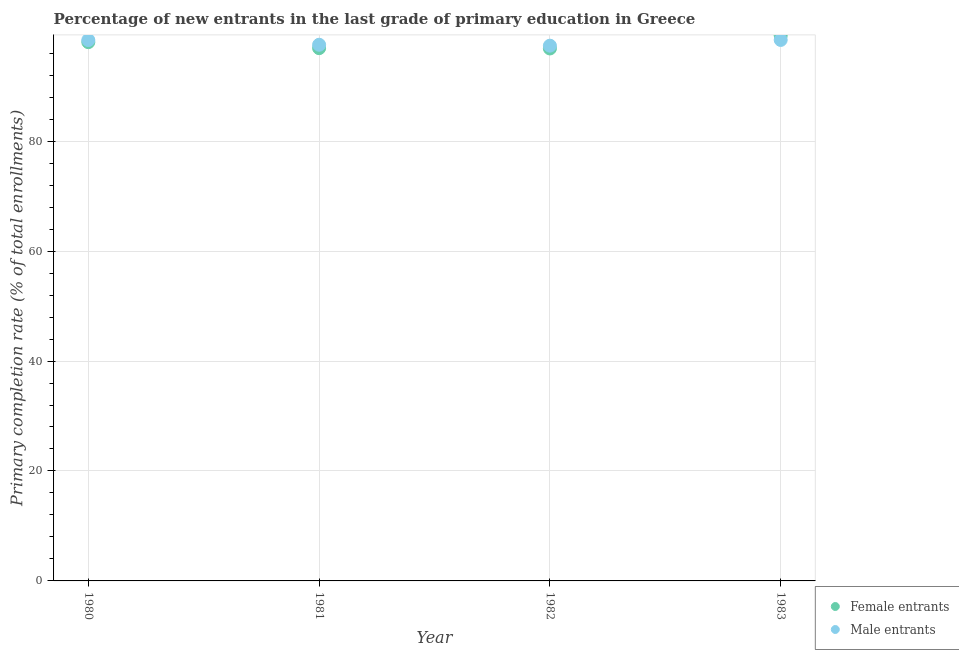What is the primary completion rate of female entrants in 1983?
Offer a very short reply. 99.21. Across all years, what is the maximum primary completion rate of male entrants?
Keep it short and to the point. 98.41. Across all years, what is the minimum primary completion rate of male entrants?
Provide a succinct answer. 97.36. In which year was the primary completion rate of female entrants maximum?
Offer a terse response. 1983. In which year was the primary completion rate of female entrants minimum?
Provide a short and direct response. 1982. What is the total primary completion rate of male entrants in the graph?
Provide a succinct answer. 391.69. What is the difference between the primary completion rate of female entrants in 1980 and that in 1981?
Offer a terse response. 1.09. What is the difference between the primary completion rate of male entrants in 1981 and the primary completion rate of female entrants in 1983?
Offer a terse response. -1.68. What is the average primary completion rate of female entrants per year?
Offer a terse response. 97.75. In the year 1983, what is the difference between the primary completion rate of male entrants and primary completion rate of female entrants?
Offer a very short reply. -0.8. In how many years, is the primary completion rate of male entrants greater than 24 %?
Keep it short and to the point. 4. What is the ratio of the primary completion rate of male entrants in 1982 to that in 1983?
Offer a very short reply. 0.99. Is the difference between the primary completion rate of female entrants in 1981 and 1983 greater than the difference between the primary completion rate of male entrants in 1981 and 1983?
Your response must be concise. No. What is the difference between the highest and the second highest primary completion rate of male entrants?
Keep it short and to the point. 0.02. What is the difference between the highest and the lowest primary completion rate of female entrants?
Ensure brevity in your answer.  2.36. In how many years, is the primary completion rate of male entrants greater than the average primary completion rate of male entrants taken over all years?
Offer a very short reply. 2. Is the sum of the primary completion rate of female entrants in 1980 and 1982 greater than the maximum primary completion rate of male entrants across all years?
Make the answer very short. Yes. How many dotlines are there?
Ensure brevity in your answer.  2. How many years are there in the graph?
Ensure brevity in your answer.  4. Does the graph contain grids?
Offer a very short reply. Yes. How many legend labels are there?
Your response must be concise. 2. How are the legend labels stacked?
Provide a succinct answer. Vertical. What is the title of the graph?
Provide a short and direct response. Percentage of new entrants in the last grade of primary education in Greece. Does "Official aid received" appear as one of the legend labels in the graph?
Ensure brevity in your answer.  No. What is the label or title of the Y-axis?
Ensure brevity in your answer.  Primary completion rate (% of total enrollments). What is the Primary completion rate (% of total enrollments) of Female entrants in 1980?
Make the answer very short. 98.01. What is the Primary completion rate (% of total enrollments) in Male entrants in 1980?
Provide a succinct answer. 98.39. What is the Primary completion rate (% of total enrollments) in Female entrants in 1981?
Your response must be concise. 96.91. What is the Primary completion rate (% of total enrollments) in Male entrants in 1981?
Your answer should be very brief. 97.53. What is the Primary completion rate (% of total enrollments) in Female entrants in 1982?
Your response must be concise. 96.86. What is the Primary completion rate (% of total enrollments) in Male entrants in 1982?
Ensure brevity in your answer.  97.36. What is the Primary completion rate (% of total enrollments) of Female entrants in 1983?
Your response must be concise. 99.21. What is the Primary completion rate (% of total enrollments) in Male entrants in 1983?
Make the answer very short. 98.41. Across all years, what is the maximum Primary completion rate (% of total enrollments) of Female entrants?
Offer a terse response. 99.21. Across all years, what is the maximum Primary completion rate (% of total enrollments) of Male entrants?
Your answer should be compact. 98.41. Across all years, what is the minimum Primary completion rate (% of total enrollments) of Female entrants?
Your answer should be compact. 96.86. Across all years, what is the minimum Primary completion rate (% of total enrollments) in Male entrants?
Provide a short and direct response. 97.36. What is the total Primary completion rate (% of total enrollments) in Female entrants in the graph?
Offer a very short reply. 390.99. What is the total Primary completion rate (% of total enrollments) of Male entrants in the graph?
Provide a succinct answer. 391.69. What is the difference between the Primary completion rate (% of total enrollments) in Female entrants in 1980 and that in 1981?
Offer a very short reply. 1.09. What is the difference between the Primary completion rate (% of total enrollments) of Male entrants in 1980 and that in 1981?
Make the answer very short. 0.86. What is the difference between the Primary completion rate (% of total enrollments) of Female entrants in 1980 and that in 1982?
Give a very brief answer. 1.15. What is the difference between the Primary completion rate (% of total enrollments) in Male entrants in 1980 and that in 1982?
Give a very brief answer. 1.03. What is the difference between the Primary completion rate (% of total enrollments) in Female entrants in 1980 and that in 1983?
Keep it short and to the point. -1.21. What is the difference between the Primary completion rate (% of total enrollments) in Male entrants in 1980 and that in 1983?
Ensure brevity in your answer.  -0.02. What is the difference between the Primary completion rate (% of total enrollments) in Female entrants in 1981 and that in 1982?
Make the answer very short. 0.06. What is the difference between the Primary completion rate (% of total enrollments) in Male entrants in 1981 and that in 1982?
Your answer should be compact. 0.17. What is the difference between the Primary completion rate (% of total enrollments) in Female entrants in 1981 and that in 1983?
Your response must be concise. -2.3. What is the difference between the Primary completion rate (% of total enrollments) of Male entrants in 1981 and that in 1983?
Make the answer very short. -0.88. What is the difference between the Primary completion rate (% of total enrollments) in Female entrants in 1982 and that in 1983?
Offer a terse response. -2.35. What is the difference between the Primary completion rate (% of total enrollments) of Male entrants in 1982 and that in 1983?
Offer a terse response. -1.04. What is the difference between the Primary completion rate (% of total enrollments) of Female entrants in 1980 and the Primary completion rate (% of total enrollments) of Male entrants in 1981?
Provide a succinct answer. 0.47. What is the difference between the Primary completion rate (% of total enrollments) of Female entrants in 1980 and the Primary completion rate (% of total enrollments) of Male entrants in 1982?
Ensure brevity in your answer.  0.64. What is the difference between the Primary completion rate (% of total enrollments) in Female entrants in 1980 and the Primary completion rate (% of total enrollments) in Male entrants in 1983?
Offer a very short reply. -0.4. What is the difference between the Primary completion rate (% of total enrollments) of Female entrants in 1981 and the Primary completion rate (% of total enrollments) of Male entrants in 1982?
Your response must be concise. -0.45. What is the difference between the Primary completion rate (% of total enrollments) of Female entrants in 1981 and the Primary completion rate (% of total enrollments) of Male entrants in 1983?
Your response must be concise. -1.5. What is the difference between the Primary completion rate (% of total enrollments) in Female entrants in 1982 and the Primary completion rate (% of total enrollments) in Male entrants in 1983?
Offer a very short reply. -1.55. What is the average Primary completion rate (% of total enrollments) of Female entrants per year?
Provide a short and direct response. 97.75. What is the average Primary completion rate (% of total enrollments) of Male entrants per year?
Ensure brevity in your answer.  97.92. In the year 1980, what is the difference between the Primary completion rate (% of total enrollments) of Female entrants and Primary completion rate (% of total enrollments) of Male entrants?
Give a very brief answer. -0.38. In the year 1981, what is the difference between the Primary completion rate (% of total enrollments) of Female entrants and Primary completion rate (% of total enrollments) of Male entrants?
Your response must be concise. -0.62. In the year 1982, what is the difference between the Primary completion rate (% of total enrollments) of Female entrants and Primary completion rate (% of total enrollments) of Male entrants?
Offer a very short reply. -0.51. In the year 1983, what is the difference between the Primary completion rate (% of total enrollments) of Female entrants and Primary completion rate (% of total enrollments) of Male entrants?
Provide a succinct answer. 0.8. What is the ratio of the Primary completion rate (% of total enrollments) in Female entrants in 1980 to that in 1981?
Offer a very short reply. 1.01. What is the ratio of the Primary completion rate (% of total enrollments) of Male entrants in 1980 to that in 1981?
Your response must be concise. 1.01. What is the ratio of the Primary completion rate (% of total enrollments) in Female entrants in 1980 to that in 1982?
Provide a short and direct response. 1.01. What is the ratio of the Primary completion rate (% of total enrollments) in Male entrants in 1980 to that in 1982?
Your response must be concise. 1.01. What is the ratio of the Primary completion rate (% of total enrollments) of Female entrants in 1980 to that in 1983?
Provide a succinct answer. 0.99. What is the ratio of the Primary completion rate (% of total enrollments) in Female entrants in 1981 to that in 1982?
Keep it short and to the point. 1. What is the ratio of the Primary completion rate (% of total enrollments) in Male entrants in 1981 to that in 1982?
Ensure brevity in your answer.  1. What is the ratio of the Primary completion rate (% of total enrollments) in Female entrants in 1981 to that in 1983?
Your response must be concise. 0.98. What is the ratio of the Primary completion rate (% of total enrollments) in Male entrants in 1981 to that in 1983?
Your answer should be compact. 0.99. What is the ratio of the Primary completion rate (% of total enrollments) in Female entrants in 1982 to that in 1983?
Provide a short and direct response. 0.98. What is the ratio of the Primary completion rate (% of total enrollments) of Male entrants in 1982 to that in 1983?
Offer a terse response. 0.99. What is the difference between the highest and the second highest Primary completion rate (% of total enrollments) in Female entrants?
Your answer should be very brief. 1.21. What is the difference between the highest and the second highest Primary completion rate (% of total enrollments) of Male entrants?
Offer a terse response. 0.02. What is the difference between the highest and the lowest Primary completion rate (% of total enrollments) in Female entrants?
Your response must be concise. 2.35. What is the difference between the highest and the lowest Primary completion rate (% of total enrollments) in Male entrants?
Keep it short and to the point. 1.04. 